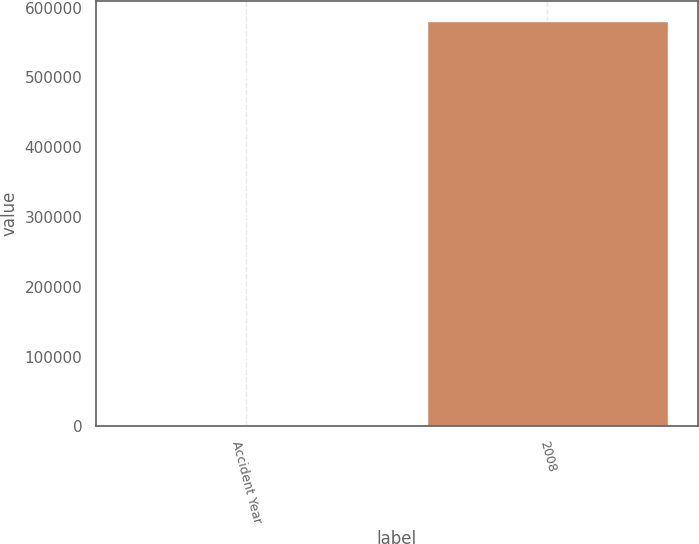Convert chart. <chart><loc_0><loc_0><loc_500><loc_500><bar_chart><fcel>Accident Year<fcel>2008<nl><fcel>2016<fcel>580845<nl></chart> 